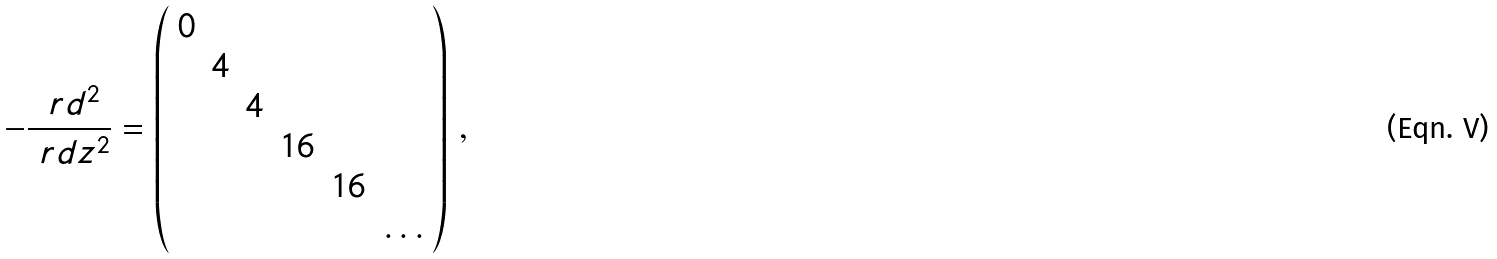<formula> <loc_0><loc_0><loc_500><loc_500>- \frac { \ r d ^ { 2 } } { \ r d z ^ { 2 } } = \left ( \begin{array} { c c c c c c } 0 & & & & & \\ & 4 & & & & \\ & & 4 & & & \\ & & & 1 6 & & \\ & & & & 1 6 & \\ & & & & & \dots \\ \end{array} \right ) \, ,</formula> 